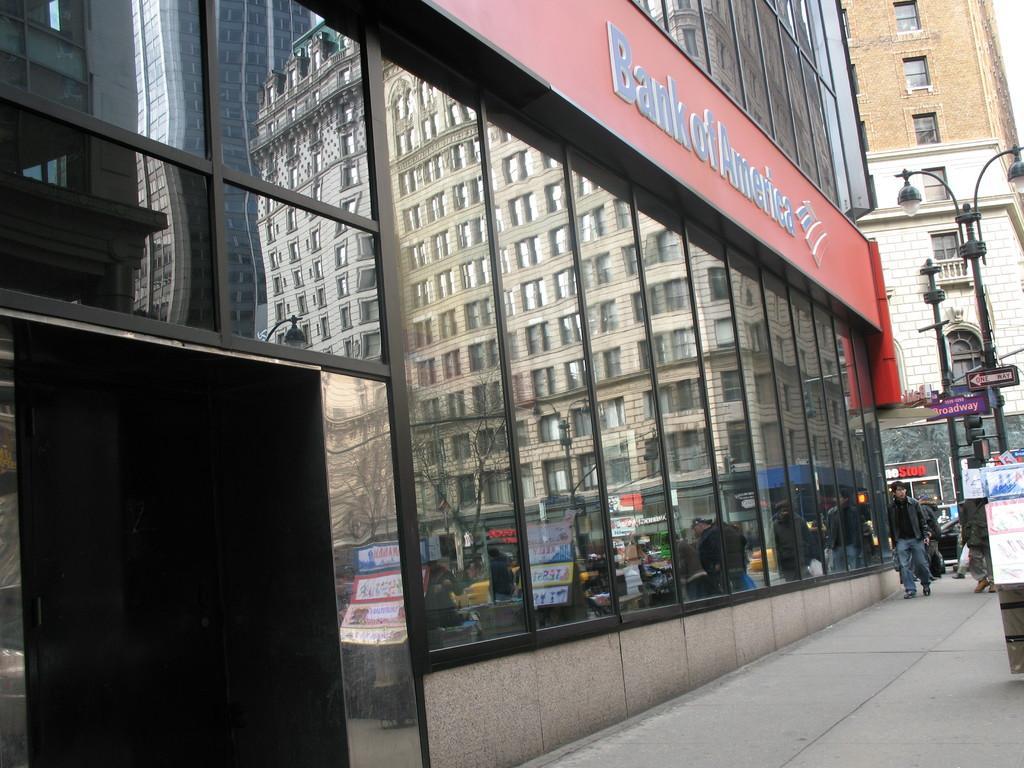Please provide a concise description of this image. There is a glass building in the center of the image, as we can see a board, on which it is written as '' Bank of america'' and there are lamp poles, people, buildings, and a car on the right side of the image and there are trees, buildings, and posters reflecting on the mirrors. 